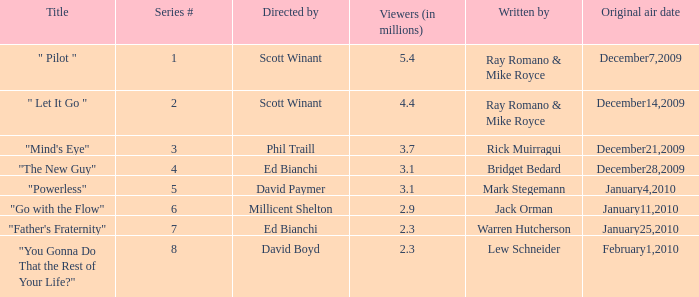What is the title of the episode written by Jack Orman? "Go with the Flow". 